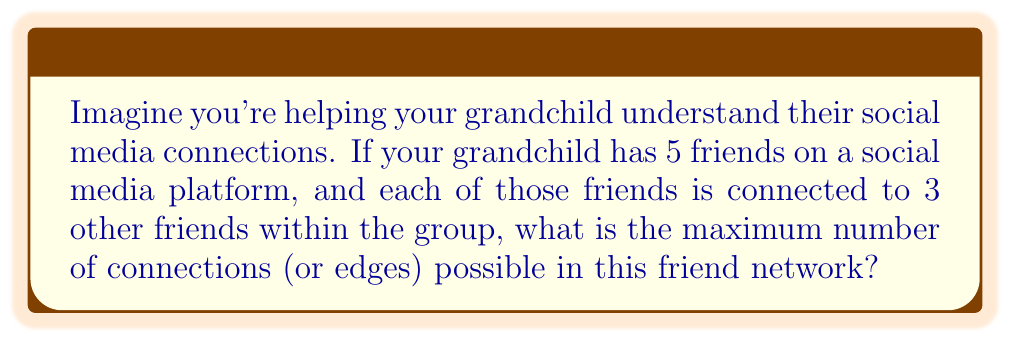Solve this math problem. Let's approach this step-by-step, using concepts from graph theory:

1) First, we need to understand what the question is asking. We're looking at a graph where:
   - There are 5 vertices (your grandchild's friends)
   - Each vertex is connected to 3 other vertices

2) In graph theory, this is known as a simple graph (no self-loops or multiple edges between the same pair of vertices).

3) The maximum number of edges in a simple graph with $n$ vertices is given by the formula:

   $$\text{Max edges} = \frac{n(n-1)}{2}$$

4) In this case, $n = 5$, so let's plug that into our formula:

   $$\text{Max edges} = \frac{5(5-1)}{2} = \frac{5(4)}{2} = \frac{20}{2} = 10$$

5) This means that in a group of 5 friends, there can be at most 10 connections between them.

6) However, the question states that each friend is connected to 3 others. We need to check if this is possible:
   - With 5 friends, each connected to 3 others, we would have $5 * 3 = 15$ connections.
   - But remember, in an undirected graph, each edge is counted twice (once for each vertex it connects).
   - So the actual number of unique connections is $15 / 2 = 7.5$

7) Since we can't have half a connection, we round down to 7.

Therefore, the maximum number of connections possible in this network, given the constraints, is 7.
Answer: 7 connections 